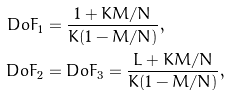Convert formula to latex. <formula><loc_0><loc_0><loc_500><loc_500>D o F _ { 1 } & = \frac { 1 + K M / N } { K ( 1 - M / N ) } , \\ D o F _ { 2 } & = D o F _ { 3 } = \frac { L + K M / N } { K ( 1 - M / N ) } ,</formula> 